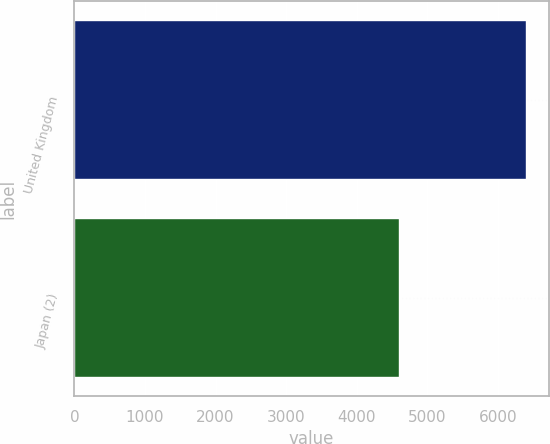<chart> <loc_0><loc_0><loc_500><loc_500><bar_chart><fcel>United Kingdom<fcel>Japan (2)<nl><fcel>6401<fcel>4603<nl></chart> 